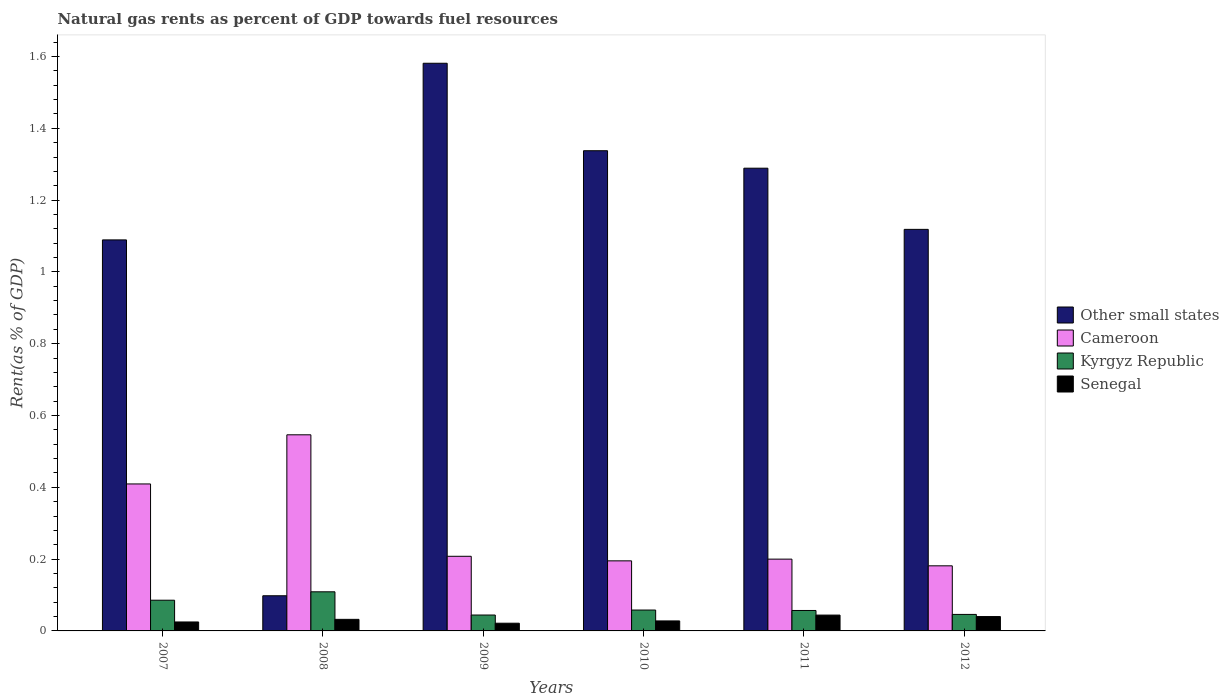How many different coloured bars are there?
Your response must be concise. 4. How many groups of bars are there?
Give a very brief answer. 6. Are the number of bars on each tick of the X-axis equal?
Give a very brief answer. Yes. In how many cases, is the number of bars for a given year not equal to the number of legend labels?
Your answer should be very brief. 0. What is the matural gas rent in Cameroon in 2010?
Offer a very short reply. 0.2. Across all years, what is the maximum matural gas rent in Cameroon?
Give a very brief answer. 0.55. Across all years, what is the minimum matural gas rent in Cameroon?
Keep it short and to the point. 0.18. In which year was the matural gas rent in Other small states maximum?
Offer a very short reply. 2009. In which year was the matural gas rent in Senegal minimum?
Make the answer very short. 2009. What is the total matural gas rent in Senegal in the graph?
Keep it short and to the point. 0.19. What is the difference between the matural gas rent in Kyrgyz Republic in 2007 and that in 2011?
Your response must be concise. 0.03. What is the difference between the matural gas rent in Kyrgyz Republic in 2008 and the matural gas rent in Other small states in 2010?
Ensure brevity in your answer.  -1.23. What is the average matural gas rent in Cameroon per year?
Provide a short and direct response. 0.29. In the year 2009, what is the difference between the matural gas rent in Senegal and matural gas rent in Other small states?
Make the answer very short. -1.56. What is the ratio of the matural gas rent in Senegal in 2010 to that in 2011?
Your answer should be compact. 0.63. Is the matural gas rent in Kyrgyz Republic in 2008 less than that in 2012?
Keep it short and to the point. No. What is the difference between the highest and the second highest matural gas rent in Cameroon?
Provide a short and direct response. 0.14. What is the difference between the highest and the lowest matural gas rent in Other small states?
Give a very brief answer. 1.48. What does the 2nd bar from the left in 2009 represents?
Your response must be concise. Cameroon. What does the 4th bar from the right in 2011 represents?
Keep it short and to the point. Other small states. Is it the case that in every year, the sum of the matural gas rent in Other small states and matural gas rent in Kyrgyz Republic is greater than the matural gas rent in Senegal?
Provide a succinct answer. Yes. How many bars are there?
Make the answer very short. 24. Are all the bars in the graph horizontal?
Ensure brevity in your answer.  No. How are the legend labels stacked?
Offer a terse response. Vertical. What is the title of the graph?
Offer a very short reply. Natural gas rents as percent of GDP towards fuel resources. Does "East Asia (developing only)" appear as one of the legend labels in the graph?
Your answer should be compact. No. What is the label or title of the Y-axis?
Make the answer very short. Rent(as % of GDP). What is the Rent(as % of GDP) in Other small states in 2007?
Your answer should be very brief. 1.09. What is the Rent(as % of GDP) of Cameroon in 2007?
Make the answer very short. 0.41. What is the Rent(as % of GDP) of Kyrgyz Republic in 2007?
Give a very brief answer. 0.09. What is the Rent(as % of GDP) of Senegal in 2007?
Offer a terse response. 0.02. What is the Rent(as % of GDP) of Other small states in 2008?
Provide a succinct answer. 0.1. What is the Rent(as % of GDP) in Cameroon in 2008?
Provide a succinct answer. 0.55. What is the Rent(as % of GDP) in Kyrgyz Republic in 2008?
Offer a very short reply. 0.11. What is the Rent(as % of GDP) of Senegal in 2008?
Give a very brief answer. 0.03. What is the Rent(as % of GDP) of Other small states in 2009?
Your response must be concise. 1.58. What is the Rent(as % of GDP) in Cameroon in 2009?
Ensure brevity in your answer.  0.21. What is the Rent(as % of GDP) of Kyrgyz Republic in 2009?
Give a very brief answer. 0.04. What is the Rent(as % of GDP) in Senegal in 2009?
Your answer should be compact. 0.02. What is the Rent(as % of GDP) of Other small states in 2010?
Your response must be concise. 1.34. What is the Rent(as % of GDP) of Cameroon in 2010?
Provide a short and direct response. 0.2. What is the Rent(as % of GDP) in Kyrgyz Republic in 2010?
Give a very brief answer. 0.06. What is the Rent(as % of GDP) in Senegal in 2010?
Provide a succinct answer. 0.03. What is the Rent(as % of GDP) in Other small states in 2011?
Keep it short and to the point. 1.29. What is the Rent(as % of GDP) in Cameroon in 2011?
Your answer should be compact. 0.2. What is the Rent(as % of GDP) of Kyrgyz Republic in 2011?
Your response must be concise. 0.06. What is the Rent(as % of GDP) in Senegal in 2011?
Provide a short and direct response. 0.04. What is the Rent(as % of GDP) of Other small states in 2012?
Your answer should be very brief. 1.12. What is the Rent(as % of GDP) of Cameroon in 2012?
Offer a terse response. 0.18. What is the Rent(as % of GDP) of Kyrgyz Republic in 2012?
Your response must be concise. 0.05. What is the Rent(as % of GDP) in Senegal in 2012?
Give a very brief answer. 0.04. Across all years, what is the maximum Rent(as % of GDP) in Other small states?
Your answer should be compact. 1.58. Across all years, what is the maximum Rent(as % of GDP) of Cameroon?
Ensure brevity in your answer.  0.55. Across all years, what is the maximum Rent(as % of GDP) of Kyrgyz Republic?
Offer a very short reply. 0.11. Across all years, what is the maximum Rent(as % of GDP) of Senegal?
Your response must be concise. 0.04. Across all years, what is the minimum Rent(as % of GDP) of Other small states?
Provide a succinct answer. 0.1. Across all years, what is the minimum Rent(as % of GDP) in Cameroon?
Give a very brief answer. 0.18. Across all years, what is the minimum Rent(as % of GDP) in Kyrgyz Republic?
Your answer should be very brief. 0.04. Across all years, what is the minimum Rent(as % of GDP) of Senegal?
Make the answer very short. 0.02. What is the total Rent(as % of GDP) of Other small states in the graph?
Give a very brief answer. 6.51. What is the total Rent(as % of GDP) in Cameroon in the graph?
Provide a short and direct response. 1.74. What is the total Rent(as % of GDP) of Kyrgyz Republic in the graph?
Your response must be concise. 0.4. What is the total Rent(as % of GDP) in Senegal in the graph?
Your answer should be compact. 0.19. What is the difference between the Rent(as % of GDP) in Cameroon in 2007 and that in 2008?
Provide a succinct answer. -0.14. What is the difference between the Rent(as % of GDP) of Kyrgyz Republic in 2007 and that in 2008?
Your response must be concise. -0.02. What is the difference between the Rent(as % of GDP) in Senegal in 2007 and that in 2008?
Ensure brevity in your answer.  -0.01. What is the difference between the Rent(as % of GDP) of Other small states in 2007 and that in 2009?
Offer a very short reply. -0.49. What is the difference between the Rent(as % of GDP) in Cameroon in 2007 and that in 2009?
Offer a terse response. 0.2. What is the difference between the Rent(as % of GDP) in Kyrgyz Republic in 2007 and that in 2009?
Give a very brief answer. 0.04. What is the difference between the Rent(as % of GDP) of Senegal in 2007 and that in 2009?
Give a very brief answer. 0. What is the difference between the Rent(as % of GDP) of Other small states in 2007 and that in 2010?
Provide a short and direct response. -0.25. What is the difference between the Rent(as % of GDP) in Cameroon in 2007 and that in 2010?
Ensure brevity in your answer.  0.21. What is the difference between the Rent(as % of GDP) in Kyrgyz Republic in 2007 and that in 2010?
Ensure brevity in your answer.  0.03. What is the difference between the Rent(as % of GDP) of Senegal in 2007 and that in 2010?
Offer a very short reply. -0. What is the difference between the Rent(as % of GDP) of Other small states in 2007 and that in 2011?
Offer a very short reply. -0.2. What is the difference between the Rent(as % of GDP) in Cameroon in 2007 and that in 2011?
Provide a short and direct response. 0.21. What is the difference between the Rent(as % of GDP) in Kyrgyz Republic in 2007 and that in 2011?
Offer a terse response. 0.03. What is the difference between the Rent(as % of GDP) of Senegal in 2007 and that in 2011?
Provide a succinct answer. -0.02. What is the difference between the Rent(as % of GDP) in Other small states in 2007 and that in 2012?
Ensure brevity in your answer.  -0.03. What is the difference between the Rent(as % of GDP) in Cameroon in 2007 and that in 2012?
Give a very brief answer. 0.23. What is the difference between the Rent(as % of GDP) of Kyrgyz Republic in 2007 and that in 2012?
Your answer should be very brief. 0.04. What is the difference between the Rent(as % of GDP) of Senegal in 2007 and that in 2012?
Offer a terse response. -0.01. What is the difference between the Rent(as % of GDP) in Other small states in 2008 and that in 2009?
Your response must be concise. -1.48. What is the difference between the Rent(as % of GDP) in Cameroon in 2008 and that in 2009?
Your answer should be compact. 0.34. What is the difference between the Rent(as % of GDP) of Kyrgyz Republic in 2008 and that in 2009?
Your response must be concise. 0.06. What is the difference between the Rent(as % of GDP) of Senegal in 2008 and that in 2009?
Provide a succinct answer. 0.01. What is the difference between the Rent(as % of GDP) in Other small states in 2008 and that in 2010?
Provide a succinct answer. -1.24. What is the difference between the Rent(as % of GDP) of Cameroon in 2008 and that in 2010?
Offer a terse response. 0.35. What is the difference between the Rent(as % of GDP) of Kyrgyz Republic in 2008 and that in 2010?
Keep it short and to the point. 0.05. What is the difference between the Rent(as % of GDP) in Senegal in 2008 and that in 2010?
Ensure brevity in your answer.  0. What is the difference between the Rent(as % of GDP) of Other small states in 2008 and that in 2011?
Your response must be concise. -1.19. What is the difference between the Rent(as % of GDP) in Cameroon in 2008 and that in 2011?
Give a very brief answer. 0.35. What is the difference between the Rent(as % of GDP) of Kyrgyz Republic in 2008 and that in 2011?
Provide a short and direct response. 0.05. What is the difference between the Rent(as % of GDP) in Senegal in 2008 and that in 2011?
Provide a succinct answer. -0.01. What is the difference between the Rent(as % of GDP) of Other small states in 2008 and that in 2012?
Keep it short and to the point. -1.02. What is the difference between the Rent(as % of GDP) of Cameroon in 2008 and that in 2012?
Provide a short and direct response. 0.36. What is the difference between the Rent(as % of GDP) of Kyrgyz Republic in 2008 and that in 2012?
Provide a succinct answer. 0.06. What is the difference between the Rent(as % of GDP) in Senegal in 2008 and that in 2012?
Provide a succinct answer. -0.01. What is the difference between the Rent(as % of GDP) in Other small states in 2009 and that in 2010?
Make the answer very short. 0.24. What is the difference between the Rent(as % of GDP) of Cameroon in 2009 and that in 2010?
Offer a terse response. 0.01. What is the difference between the Rent(as % of GDP) in Kyrgyz Republic in 2009 and that in 2010?
Your response must be concise. -0.01. What is the difference between the Rent(as % of GDP) of Senegal in 2009 and that in 2010?
Ensure brevity in your answer.  -0.01. What is the difference between the Rent(as % of GDP) in Other small states in 2009 and that in 2011?
Offer a terse response. 0.29. What is the difference between the Rent(as % of GDP) in Cameroon in 2009 and that in 2011?
Keep it short and to the point. 0.01. What is the difference between the Rent(as % of GDP) of Kyrgyz Republic in 2009 and that in 2011?
Make the answer very short. -0.01. What is the difference between the Rent(as % of GDP) in Senegal in 2009 and that in 2011?
Keep it short and to the point. -0.02. What is the difference between the Rent(as % of GDP) in Other small states in 2009 and that in 2012?
Provide a short and direct response. 0.46. What is the difference between the Rent(as % of GDP) in Cameroon in 2009 and that in 2012?
Offer a terse response. 0.03. What is the difference between the Rent(as % of GDP) in Kyrgyz Republic in 2009 and that in 2012?
Provide a short and direct response. -0. What is the difference between the Rent(as % of GDP) in Senegal in 2009 and that in 2012?
Your answer should be compact. -0.02. What is the difference between the Rent(as % of GDP) of Other small states in 2010 and that in 2011?
Offer a terse response. 0.05. What is the difference between the Rent(as % of GDP) of Cameroon in 2010 and that in 2011?
Offer a terse response. -0. What is the difference between the Rent(as % of GDP) in Kyrgyz Republic in 2010 and that in 2011?
Make the answer very short. 0. What is the difference between the Rent(as % of GDP) of Senegal in 2010 and that in 2011?
Ensure brevity in your answer.  -0.02. What is the difference between the Rent(as % of GDP) in Other small states in 2010 and that in 2012?
Make the answer very short. 0.22. What is the difference between the Rent(as % of GDP) in Cameroon in 2010 and that in 2012?
Ensure brevity in your answer.  0.01. What is the difference between the Rent(as % of GDP) of Kyrgyz Republic in 2010 and that in 2012?
Provide a succinct answer. 0.01. What is the difference between the Rent(as % of GDP) in Senegal in 2010 and that in 2012?
Offer a very short reply. -0.01. What is the difference between the Rent(as % of GDP) in Other small states in 2011 and that in 2012?
Provide a succinct answer. 0.17. What is the difference between the Rent(as % of GDP) of Cameroon in 2011 and that in 2012?
Your answer should be compact. 0.02. What is the difference between the Rent(as % of GDP) in Kyrgyz Republic in 2011 and that in 2012?
Provide a succinct answer. 0.01. What is the difference between the Rent(as % of GDP) of Senegal in 2011 and that in 2012?
Your response must be concise. 0. What is the difference between the Rent(as % of GDP) in Other small states in 2007 and the Rent(as % of GDP) in Cameroon in 2008?
Your answer should be very brief. 0.54. What is the difference between the Rent(as % of GDP) in Other small states in 2007 and the Rent(as % of GDP) in Kyrgyz Republic in 2008?
Your response must be concise. 0.98. What is the difference between the Rent(as % of GDP) of Other small states in 2007 and the Rent(as % of GDP) of Senegal in 2008?
Keep it short and to the point. 1.06. What is the difference between the Rent(as % of GDP) in Cameroon in 2007 and the Rent(as % of GDP) in Kyrgyz Republic in 2008?
Ensure brevity in your answer.  0.3. What is the difference between the Rent(as % of GDP) of Cameroon in 2007 and the Rent(as % of GDP) of Senegal in 2008?
Your answer should be very brief. 0.38. What is the difference between the Rent(as % of GDP) in Kyrgyz Republic in 2007 and the Rent(as % of GDP) in Senegal in 2008?
Keep it short and to the point. 0.05. What is the difference between the Rent(as % of GDP) in Other small states in 2007 and the Rent(as % of GDP) in Cameroon in 2009?
Make the answer very short. 0.88. What is the difference between the Rent(as % of GDP) of Other small states in 2007 and the Rent(as % of GDP) of Kyrgyz Republic in 2009?
Give a very brief answer. 1.04. What is the difference between the Rent(as % of GDP) of Other small states in 2007 and the Rent(as % of GDP) of Senegal in 2009?
Provide a succinct answer. 1.07. What is the difference between the Rent(as % of GDP) of Cameroon in 2007 and the Rent(as % of GDP) of Kyrgyz Republic in 2009?
Ensure brevity in your answer.  0.37. What is the difference between the Rent(as % of GDP) in Cameroon in 2007 and the Rent(as % of GDP) in Senegal in 2009?
Offer a very short reply. 0.39. What is the difference between the Rent(as % of GDP) of Kyrgyz Republic in 2007 and the Rent(as % of GDP) of Senegal in 2009?
Make the answer very short. 0.06. What is the difference between the Rent(as % of GDP) of Other small states in 2007 and the Rent(as % of GDP) of Cameroon in 2010?
Offer a very short reply. 0.89. What is the difference between the Rent(as % of GDP) in Other small states in 2007 and the Rent(as % of GDP) in Kyrgyz Republic in 2010?
Provide a short and direct response. 1.03. What is the difference between the Rent(as % of GDP) in Other small states in 2007 and the Rent(as % of GDP) in Senegal in 2010?
Make the answer very short. 1.06. What is the difference between the Rent(as % of GDP) of Cameroon in 2007 and the Rent(as % of GDP) of Kyrgyz Republic in 2010?
Provide a short and direct response. 0.35. What is the difference between the Rent(as % of GDP) of Cameroon in 2007 and the Rent(as % of GDP) of Senegal in 2010?
Ensure brevity in your answer.  0.38. What is the difference between the Rent(as % of GDP) of Kyrgyz Republic in 2007 and the Rent(as % of GDP) of Senegal in 2010?
Give a very brief answer. 0.06. What is the difference between the Rent(as % of GDP) in Other small states in 2007 and the Rent(as % of GDP) in Cameroon in 2011?
Keep it short and to the point. 0.89. What is the difference between the Rent(as % of GDP) in Other small states in 2007 and the Rent(as % of GDP) in Kyrgyz Republic in 2011?
Your response must be concise. 1.03. What is the difference between the Rent(as % of GDP) of Other small states in 2007 and the Rent(as % of GDP) of Senegal in 2011?
Make the answer very short. 1.05. What is the difference between the Rent(as % of GDP) of Cameroon in 2007 and the Rent(as % of GDP) of Kyrgyz Republic in 2011?
Keep it short and to the point. 0.35. What is the difference between the Rent(as % of GDP) of Cameroon in 2007 and the Rent(as % of GDP) of Senegal in 2011?
Your answer should be compact. 0.37. What is the difference between the Rent(as % of GDP) of Kyrgyz Republic in 2007 and the Rent(as % of GDP) of Senegal in 2011?
Provide a succinct answer. 0.04. What is the difference between the Rent(as % of GDP) of Other small states in 2007 and the Rent(as % of GDP) of Cameroon in 2012?
Give a very brief answer. 0.91. What is the difference between the Rent(as % of GDP) in Other small states in 2007 and the Rent(as % of GDP) in Kyrgyz Republic in 2012?
Give a very brief answer. 1.04. What is the difference between the Rent(as % of GDP) in Other small states in 2007 and the Rent(as % of GDP) in Senegal in 2012?
Provide a succinct answer. 1.05. What is the difference between the Rent(as % of GDP) in Cameroon in 2007 and the Rent(as % of GDP) in Kyrgyz Republic in 2012?
Provide a succinct answer. 0.36. What is the difference between the Rent(as % of GDP) in Cameroon in 2007 and the Rent(as % of GDP) in Senegal in 2012?
Give a very brief answer. 0.37. What is the difference between the Rent(as % of GDP) of Kyrgyz Republic in 2007 and the Rent(as % of GDP) of Senegal in 2012?
Your answer should be compact. 0.05. What is the difference between the Rent(as % of GDP) in Other small states in 2008 and the Rent(as % of GDP) in Cameroon in 2009?
Keep it short and to the point. -0.11. What is the difference between the Rent(as % of GDP) of Other small states in 2008 and the Rent(as % of GDP) of Kyrgyz Republic in 2009?
Your answer should be very brief. 0.05. What is the difference between the Rent(as % of GDP) of Other small states in 2008 and the Rent(as % of GDP) of Senegal in 2009?
Your answer should be very brief. 0.08. What is the difference between the Rent(as % of GDP) in Cameroon in 2008 and the Rent(as % of GDP) in Kyrgyz Republic in 2009?
Ensure brevity in your answer.  0.5. What is the difference between the Rent(as % of GDP) of Cameroon in 2008 and the Rent(as % of GDP) of Senegal in 2009?
Offer a very short reply. 0.52. What is the difference between the Rent(as % of GDP) of Kyrgyz Republic in 2008 and the Rent(as % of GDP) of Senegal in 2009?
Your response must be concise. 0.09. What is the difference between the Rent(as % of GDP) in Other small states in 2008 and the Rent(as % of GDP) in Cameroon in 2010?
Ensure brevity in your answer.  -0.1. What is the difference between the Rent(as % of GDP) in Other small states in 2008 and the Rent(as % of GDP) in Kyrgyz Republic in 2010?
Ensure brevity in your answer.  0.04. What is the difference between the Rent(as % of GDP) of Other small states in 2008 and the Rent(as % of GDP) of Senegal in 2010?
Give a very brief answer. 0.07. What is the difference between the Rent(as % of GDP) of Cameroon in 2008 and the Rent(as % of GDP) of Kyrgyz Republic in 2010?
Your answer should be compact. 0.49. What is the difference between the Rent(as % of GDP) of Cameroon in 2008 and the Rent(as % of GDP) of Senegal in 2010?
Give a very brief answer. 0.52. What is the difference between the Rent(as % of GDP) in Kyrgyz Republic in 2008 and the Rent(as % of GDP) in Senegal in 2010?
Give a very brief answer. 0.08. What is the difference between the Rent(as % of GDP) of Other small states in 2008 and the Rent(as % of GDP) of Cameroon in 2011?
Offer a terse response. -0.1. What is the difference between the Rent(as % of GDP) in Other small states in 2008 and the Rent(as % of GDP) in Kyrgyz Republic in 2011?
Your answer should be very brief. 0.04. What is the difference between the Rent(as % of GDP) of Other small states in 2008 and the Rent(as % of GDP) of Senegal in 2011?
Give a very brief answer. 0.05. What is the difference between the Rent(as % of GDP) in Cameroon in 2008 and the Rent(as % of GDP) in Kyrgyz Republic in 2011?
Your answer should be compact. 0.49. What is the difference between the Rent(as % of GDP) of Cameroon in 2008 and the Rent(as % of GDP) of Senegal in 2011?
Offer a terse response. 0.5. What is the difference between the Rent(as % of GDP) of Kyrgyz Republic in 2008 and the Rent(as % of GDP) of Senegal in 2011?
Keep it short and to the point. 0.06. What is the difference between the Rent(as % of GDP) in Other small states in 2008 and the Rent(as % of GDP) in Cameroon in 2012?
Keep it short and to the point. -0.08. What is the difference between the Rent(as % of GDP) of Other small states in 2008 and the Rent(as % of GDP) of Kyrgyz Republic in 2012?
Your answer should be very brief. 0.05. What is the difference between the Rent(as % of GDP) of Other small states in 2008 and the Rent(as % of GDP) of Senegal in 2012?
Keep it short and to the point. 0.06. What is the difference between the Rent(as % of GDP) in Cameroon in 2008 and the Rent(as % of GDP) in Kyrgyz Republic in 2012?
Provide a succinct answer. 0.5. What is the difference between the Rent(as % of GDP) of Cameroon in 2008 and the Rent(as % of GDP) of Senegal in 2012?
Provide a short and direct response. 0.51. What is the difference between the Rent(as % of GDP) of Kyrgyz Republic in 2008 and the Rent(as % of GDP) of Senegal in 2012?
Offer a terse response. 0.07. What is the difference between the Rent(as % of GDP) of Other small states in 2009 and the Rent(as % of GDP) of Cameroon in 2010?
Your response must be concise. 1.39. What is the difference between the Rent(as % of GDP) in Other small states in 2009 and the Rent(as % of GDP) in Kyrgyz Republic in 2010?
Keep it short and to the point. 1.52. What is the difference between the Rent(as % of GDP) of Other small states in 2009 and the Rent(as % of GDP) of Senegal in 2010?
Your response must be concise. 1.55. What is the difference between the Rent(as % of GDP) of Cameroon in 2009 and the Rent(as % of GDP) of Kyrgyz Republic in 2010?
Keep it short and to the point. 0.15. What is the difference between the Rent(as % of GDP) of Cameroon in 2009 and the Rent(as % of GDP) of Senegal in 2010?
Provide a succinct answer. 0.18. What is the difference between the Rent(as % of GDP) of Kyrgyz Republic in 2009 and the Rent(as % of GDP) of Senegal in 2010?
Your response must be concise. 0.02. What is the difference between the Rent(as % of GDP) of Other small states in 2009 and the Rent(as % of GDP) of Cameroon in 2011?
Make the answer very short. 1.38. What is the difference between the Rent(as % of GDP) of Other small states in 2009 and the Rent(as % of GDP) of Kyrgyz Republic in 2011?
Provide a succinct answer. 1.52. What is the difference between the Rent(as % of GDP) of Other small states in 2009 and the Rent(as % of GDP) of Senegal in 2011?
Ensure brevity in your answer.  1.54. What is the difference between the Rent(as % of GDP) of Cameroon in 2009 and the Rent(as % of GDP) of Kyrgyz Republic in 2011?
Ensure brevity in your answer.  0.15. What is the difference between the Rent(as % of GDP) of Cameroon in 2009 and the Rent(as % of GDP) of Senegal in 2011?
Offer a very short reply. 0.16. What is the difference between the Rent(as % of GDP) in Other small states in 2009 and the Rent(as % of GDP) in Cameroon in 2012?
Ensure brevity in your answer.  1.4. What is the difference between the Rent(as % of GDP) in Other small states in 2009 and the Rent(as % of GDP) in Kyrgyz Republic in 2012?
Provide a short and direct response. 1.54. What is the difference between the Rent(as % of GDP) in Other small states in 2009 and the Rent(as % of GDP) in Senegal in 2012?
Your answer should be compact. 1.54. What is the difference between the Rent(as % of GDP) of Cameroon in 2009 and the Rent(as % of GDP) of Kyrgyz Republic in 2012?
Give a very brief answer. 0.16. What is the difference between the Rent(as % of GDP) in Cameroon in 2009 and the Rent(as % of GDP) in Senegal in 2012?
Provide a short and direct response. 0.17. What is the difference between the Rent(as % of GDP) in Kyrgyz Republic in 2009 and the Rent(as % of GDP) in Senegal in 2012?
Offer a terse response. 0. What is the difference between the Rent(as % of GDP) in Other small states in 2010 and the Rent(as % of GDP) in Cameroon in 2011?
Your answer should be compact. 1.14. What is the difference between the Rent(as % of GDP) in Other small states in 2010 and the Rent(as % of GDP) in Kyrgyz Republic in 2011?
Your answer should be very brief. 1.28. What is the difference between the Rent(as % of GDP) in Other small states in 2010 and the Rent(as % of GDP) in Senegal in 2011?
Offer a terse response. 1.29. What is the difference between the Rent(as % of GDP) in Cameroon in 2010 and the Rent(as % of GDP) in Kyrgyz Republic in 2011?
Keep it short and to the point. 0.14. What is the difference between the Rent(as % of GDP) of Cameroon in 2010 and the Rent(as % of GDP) of Senegal in 2011?
Offer a terse response. 0.15. What is the difference between the Rent(as % of GDP) of Kyrgyz Republic in 2010 and the Rent(as % of GDP) of Senegal in 2011?
Make the answer very short. 0.01. What is the difference between the Rent(as % of GDP) of Other small states in 2010 and the Rent(as % of GDP) of Cameroon in 2012?
Keep it short and to the point. 1.16. What is the difference between the Rent(as % of GDP) of Other small states in 2010 and the Rent(as % of GDP) of Kyrgyz Republic in 2012?
Give a very brief answer. 1.29. What is the difference between the Rent(as % of GDP) in Other small states in 2010 and the Rent(as % of GDP) in Senegal in 2012?
Offer a very short reply. 1.3. What is the difference between the Rent(as % of GDP) in Cameroon in 2010 and the Rent(as % of GDP) in Kyrgyz Republic in 2012?
Keep it short and to the point. 0.15. What is the difference between the Rent(as % of GDP) of Cameroon in 2010 and the Rent(as % of GDP) of Senegal in 2012?
Make the answer very short. 0.16. What is the difference between the Rent(as % of GDP) of Kyrgyz Republic in 2010 and the Rent(as % of GDP) of Senegal in 2012?
Provide a short and direct response. 0.02. What is the difference between the Rent(as % of GDP) in Other small states in 2011 and the Rent(as % of GDP) in Cameroon in 2012?
Give a very brief answer. 1.11. What is the difference between the Rent(as % of GDP) in Other small states in 2011 and the Rent(as % of GDP) in Kyrgyz Republic in 2012?
Give a very brief answer. 1.24. What is the difference between the Rent(as % of GDP) of Other small states in 2011 and the Rent(as % of GDP) of Senegal in 2012?
Ensure brevity in your answer.  1.25. What is the difference between the Rent(as % of GDP) in Cameroon in 2011 and the Rent(as % of GDP) in Kyrgyz Republic in 2012?
Provide a short and direct response. 0.15. What is the difference between the Rent(as % of GDP) in Cameroon in 2011 and the Rent(as % of GDP) in Senegal in 2012?
Provide a succinct answer. 0.16. What is the difference between the Rent(as % of GDP) of Kyrgyz Republic in 2011 and the Rent(as % of GDP) of Senegal in 2012?
Offer a very short reply. 0.02. What is the average Rent(as % of GDP) in Other small states per year?
Give a very brief answer. 1.09. What is the average Rent(as % of GDP) in Cameroon per year?
Ensure brevity in your answer.  0.29. What is the average Rent(as % of GDP) of Kyrgyz Republic per year?
Your answer should be compact. 0.07. What is the average Rent(as % of GDP) in Senegal per year?
Offer a terse response. 0.03. In the year 2007, what is the difference between the Rent(as % of GDP) in Other small states and Rent(as % of GDP) in Cameroon?
Provide a succinct answer. 0.68. In the year 2007, what is the difference between the Rent(as % of GDP) of Other small states and Rent(as % of GDP) of Kyrgyz Republic?
Ensure brevity in your answer.  1. In the year 2007, what is the difference between the Rent(as % of GDP) in Other small states and Rent(as % of GDP) in Senegal?
Your response must be concise. 1.06. In the year 2007, what is the difference between the Rent(as % of GDP) of Cameroon and Rent(as % of GDP) of Kyrgyz Republic?
Ensure brevity in your answer.  0.32. In the year 2007, what is the difference between the Rent(as % of GDP) in Cameroon and Rent(as % of GDP) in Senegal?
Give a very brief answer. 0.38. In the year 2007, what is the difference between the Rent(as % of GDP) in Kyrgyz Republic and Rent(as % of GDP) in Senegal?
Keep it short and to the point. 0.06. In the year 2008, what is the difference between the Rent(as % of GDP) of Other small states and Rent(as % of GDP) of Cameroon?
Your answer should be compact. -0.45. In the year 2008, what is the difference between the Rent(as % of GDP) in Other small states and Rent(as % of GDP) in Kyrgyz Republic?
Make the answer very short. -0.01. In the year 2008, what is the difference between the Rent(as % of GDP) of Other small states and Rent(as % of GDP) of Senegal?
Ensure brevity in your answer.  0.07. In the year 2008, what is the difference between the Rent(as % of GDP) in Cameroon and Rent(as % of GDP) in Kyrgyz Republic?
Your response must be concise. 0.44. In the year 2008, what is the difference between the Rent(as % of GDP) in Cameroon and Rent(as % of GDP) in Senegal?
Provide a succinct answer. 0.51. In the year 2008, what is the difference between the Rent(as % of GDP) of Kyrgyz Republic and Rent(as % of GDP) of Senegal?
Provide a succinct answer. 0.08. In the year 2009, what is the difference between the Rent(as % of GDP) in Other small states and Rent(as % of GDP) in Cameroon?
Your response must be concise. 1.37. In the year 2009, what is the difference between the Rent(as % of GDP) in Other small states and Rent(as % of GDP) in Kyrgyz Republic?
Your response must be concise. 1.54. In the year 2009, what is the difference between the Rent(as % of GDP) in Other small states and Rent(as % of GDP) in Senegal?
Offer a terse response. 1.56. In the year 2009, what is the difference between the Rent(as % of GDP) in Cameroon and Rent(as % of GDP) in Kyrgyz Republic?
Your answer should be very brief. 0.16. In the year 2009, what is the difference between the Rent(as % of GDP) of Cameroon and Rent(as % of GDP) of Senegal?
Offer a terse response. 0.19. In the year 2009, what is the difference between the Rent(as % of GDP) of Kyrgyz Republic and Rent(as % of GDP) of Senegal?
Offer a very short reply. 0.02. In the year 2010, what is the difference between the Rent(as % of GDP) in Other small states and Rent(as % of GDP) in Cameroon?
Ensure brevity in your answer.  1.14. In the year 2010, what is the difference between the Rent(as % of GDP) of Other small states and Rent(as % of GDP) of Kyrgyz Republic?
Ensure brevity in your answer.  1.28. In the year 2010, what is the difference between the Rent(as % of GDP) of Other small states and Rent(as % of GDP) of Senegal?
Give a very brief answer. 1.31. In the year 2010, what is the difference between the Rent(as % of GDP) of Cameroon and Rent(as % of GDP) of Kyrgyz Republic?
Provide a short and direct response. 0.14. In the year 2010, what is the difference between the Rent(as % of GDP) of Cameroon and Rent(as % of GDP) of Senegal?
Make the answer very short. 0.17. In the year 2010, what is the difference between the Rent(as % of GDP) of Kyrgyz Republic and Rent(as % of GDP) of Senegal?
Your response must be concise. 0.03. In the year 2011, what is the difference between the Rent(as % of GDP) of Other small states and Rent(as % of GDP) of Cameroon?
Give a very brief answer. 1.09. In the year 2011, what is the difference between the Rent(as % of GDP) of Other small states and Rent(as % of GDP) of Kyrgyz Republic?
Provide a short and direct response. 1.23. In the year 2011, what is the difference between the Rent(as % of GDP) in Other small states and Rent(as % of GDP) in Senegal?
Provide a short and direct response. 1.24. In the year 2011, what is the difference between the Rent(as % of GDP) in Cameroon and Rent(as % of GDP) in Kyrgyz Republic?
Your response must be concise. 0.14. In the year 2011, what is the difference between the Rent(as % of GDP) in Cameroon and Rent(as % of GDP) in Senegal?
Offer a terse response. 0.16. In the year 2011, what is the difference between the Rent(as % of GDP) of Kyrgyz Republic and Rent(as % of GDP) of Senegal?
Make the answer very short. 0.01. In the year 2012, what is the difference between the Rent(as % of GDP) in Other small states and Rent(as % of GDP) in Cameroon?
Provide a short and direct response. 0.94. In the year 2012, what is the difference between the Rent(as % of GDP) in Other small states and Rent(as % of GDP) in Kyrgyz Republic?
Your response must be concise. 1.07. In the year 2012, what is the difference between the Rent(as % of GDP) in Other small states and Rent(as % of GDP) in Senegal?
Give a very brief answer. 1.08. In the year 2012, what is the difference between the Rent(as % of GDP) of Cameroon and Rent(as % of GDP) of Kyrgyz Republic?
Ensure brevity in your answer.  0.14. In the year 2012, what is the difference between the Rent(as % of GDP) of Cameroon and Rent(as % of GDP) of Senegal?
Provide a succinct answer. 0.14. In the year 2012, what is the difference between the Rent(as % of GDP) of Kyrgyz Republic and Rent(as % of GDP) of Senegal?
Provide a short and direct response. 0.01. What is the ratio of the Rent(as % of GDP) in Other small states in 2007 to that in 2008?
Provide a short and direct response. 11.12. What is the ratio of the Rent(as % of GDP) in Cameroon in 2007 to that in 2008?
Make the answer very short. 0.75. What is the ratio of the Rent(as % of GDP) of Kyrgyz Republic in 2007 to that in 2008?
Provide a short and direct response. 0.79. What is the ratio of the Rent(as % of GDP) in Senegal in 2007 to that in 2008?
Ensure brevity in your answer.  0.77. What is the ratio of the Rent(as % of GDP) of Other small states in 2007 to that in 2009?
Your response must be concise. 0.69. What is the ratio of the Rent(as % of GDP) of Cameroon in 2007 to that in 2009?
Provide a succinct answer. 1.97. What is the ratio of the Rent(as % of GDP) of Kyrgyz Republic in 2007 to that in 2009?
Offer a very short reply. 1.93. What is the ratio of the Rent(as % of GDP) of Senegal in 2007 to that in 2009?
Your answer should be very brief. 1.16. What is the ratio of the Rent(as % of GDP) of Other small states in 2007 to that in 2010?
Offer a terse response. 0.81. What is the ratio of the Rent(as % of GDP) in Cameroon in 2007 to that in 2010?
Your answer should be compact. 2.1. What is the ratio of the Rent(as % of GDP) in Kyrgyz Republic in 2007 to that in 2010?
Your response must be concise. 1.47. What is the ratio of the Rent(as % of GDP) of Senegal in 2007 to that in 2010?
Give a very brief answer. 0.9. What is the ratio of the Rent(as % of GDP) of Other small states in 2007 to that in 2011?
Make the answer very short. 0.85. What is the ratio of the Rent(as % of GDP) of Cameroon in 2007 to that in 2011?
Keep it short and to the point. 2.05. What is the ratio of the Rent(as % of GDP) of Kyrgyz Republic in 2007 to that in 2011?
Make the answer very short. 1.5. What is the ratio of the Rent(as % of GDP) in Senegal in 2007 to that in 2011?
Your answer should be very brief. 0.57. What is the ratio of the Rent(as % of GDP) in Other small states in 2007 to that in 2012?
Provide a succinct answer. 0.97. What is the ratio of the Rent(as % of GDP) in Cameroon in 2007 to that in 2012?
Make the answer very short. 2.26. What is the ratio of the Rent(as % of GDP) in Kyrgyz Republic in 2007 to that in 2012?
Offer a very short reply. 1.86. What is the ratio of the Rent(as % of GDP) in Senegal in 2007 to that in 2012?
Provide a succinct answer. 0.62. What is the ratio of the Rent(as % of GDP) in Other small states in 2008 to that in 2009?
Your answer should be compact. 0.06. What is the ratio of the Rent(as % of GDP) of Cameroon in 2008 to that in 2009?
Ensure brevity in your answer.  2.63. What is the ratio of the Rent(as % of GDP) of Kyrgyz Republic in 2008 to that in 2009?
Make the answer very short. 2.46. What is the ratio of the Rent(as % of GDP) in Senegal in 2008 to that in 2009?
Provide a short and direct response. 1.5. What is the ratio of the Rent(as % of GDP) in Other small states in 2008 to that in 2010?
Ensure brevity in your answer.  0.07. What is the ratio of the Rent(as % of GDP) in Cameroon in 2008 to that in 2010?
Provide a succinct answer. 2.8. What is the ratio of the Rent(as % of GDP) of Kyrgyz Republic in 2008 to that in 2010?
Your response must be concise. 1.87. What is the ratio of the Rent(as % of GDP) of Senegal in 2008 to that in 2010?
Keep it short and to the point. 1.16. What is the ratio of the Rent(as % of GDP) of Other small states in 2008 to that in 2011?
Your answer should be compact. 0.08. What is the ratio of the Rent(as % of GDP) of Cameroon in 2008 to that in 2011?
Your answer should be very brief. 2.73. What is the ratio of the Rent(as % of GDP) in Kyrgyz Republic in 2008 to that in 2011?
Your answer should be compact. 1.91. What is the ratio of the Rent(as % of GDP) of Senegal in 2008 to that in 2011?
Provide a short and direct response. 0.73. What is the ratio of the Rent(as % of GDP) of Other small states in 2008 to that in 2012?
Give a very brief answer. 0.09. What is the ratio of the Rent(as % of GDP) of Cameroon in 2008 to that in 2012?
Offer a terse response. 3.01. What is the ratio of the Rent(as % of GDP) of Kyrgyz Republic in 2008 to that in 2012?
Keep it short and to the point. 2.37. What is the ratio of the Rent(as % of GDP) of Senegal in 2008 to that in 2012?
Ensure brevity in your answer.  0.81. What is the ratio of the Rent(as % of GDP) of Other small states in 2009 to that in 2010?
Offer a very short reply. 1.18. What is the ratio of the Rent(as % of GDP) of Cameroon in 2009 to that in 2010?
Offer a terse response. 1.06. What is the ratio of the Rent(as % of GDP) in Kyrgyz Republic in 2009 to that in 2010?
Offer a terse response. 0.76. What is the ratio of the Rent(as % of GDP) in Senegal in 2009 to that in 2010?
Your response must be concise. 0.77. What is the ratio of the Rent(as % of GDP) in Other small states in 2009 to that in 2011?
Your answer should be very brief. 1.23. What is the ratio of the Rent(as % of GDP) of Cameroon in 2009 to that in 2011?
Provide a succinct answer. 1.04. What is the ratio of the Rent(as % of GDP) of Kyrgyz Republic in 2009 to that in 2011?
Provide a short and direct response. 0.78. What is the ratio of the Rent(as % of GDP) in Senegal in 2009 to that in 2011?
Your response must be concise. 0.49. What is the ratio of the Rent(as % of GDP) in Other small states in 2009 to that in 2012?
Your answer should be very brief. 1.41. What is the ratio of the Rent(as % of GDP) of Cameroon in 2009 to that in 2012?
Keep it short and to the point. 1.15. What is the ratio of the Rent(as % of GDP) in Kyrgyz Republic in 2009 to that in 2012?
Your answer should be compact. 0.96. What is the ratio of the Rent(as % of GDP) of Senegal in 2009 to that in 2012?
Provide a succinct answer. 0.54. What is the ratio of the Rent(as % of GDP) in Other small states in 2010 to that in 2011?
Your response must be concise. 1.04. What is the ratio of the Rent(as % of GDP) in Cameroon in 2010 to that in 2011?
Ensure brevity in your answer.  0.98. What is the ratio of the Rent(as % of GDP) of Kyrgyz Republic in 2010 to that in 2011?
Provide a succinct answer. 1.02. What is the ratio of the Rent(as % of GDP) of Senegal in 2010 to that in 2011?
Give a very brief answer. 0.63. What is the ratio of the Rent(as % of GDP) in Other small states in 2010 to that in 2012?
Keep it short and to the point. 1.2. What is the ratio of the Rent(as % of GDP) in Cameroon in 2010 to that in 2012?
Ensure brevity in your answer.  1.08. What is the ratio of the Rent(as % of GDP) of Kyrgyz Republic in 2010 to that in 2012?
Keep it short and to the point. 1.26. What is the ratio of the Rent(as % of GDP) in Senegal in 2010 to that in 2012?
Ensure brevity in your answer.  0.7. What is the ratio of the Rent(as % of GDP) in Other small states in 2011 to that in 2012?
Offer a very short reply. 1.15. What is the ratio of the Rent(as % of GDP) in Cameroon in 2011 to that in 2012?
Your answer should be compact. 1.1. What is the ratio of the Rent(as % of GDP) in Kyrgyz Republic in 2011 to that in 2012?
Offer a terse response. 1.24. What is the ratio of the Rent(as % of GDP) of Senegal in 2011 to that in 2012?
Keep it short and to the point. 1.1. What is the difference between the highest and the second highest Rent(as % of GDP) of Other small states?
Offer a very short reply. 0.24. What is the difference between the highest and the second highest Rent(as % of GDP) in Cameroon?
Provide a succinct answer. 0.14. What is the difference between the highest and the second highest Rent(as % of GDP) in Kyrgyz Republic?
Your answer should be compact. 0.02. What is the difference between the highest and the second highest Rent(as % of GDP) in Senegal?
Your answer should be compact. 0. What is the difference between the highest and the lowest Rent(as % of GDP) of Other small states?
Give a very brief answer. 1.48. What is the difference between the highest and the lowest Rent(as % of GDP) in Cameroon?
Offer a very short reply. 0.36. What is the difference between the highest and the lowest Rent(as % of GDP) of Kyrgyz Republic?
Make the answer very short. 0.06. What is the difference between the highest and the lowest Rent(as % of GDP) in Senegal?
Your answer should be very brief. 0.02. 